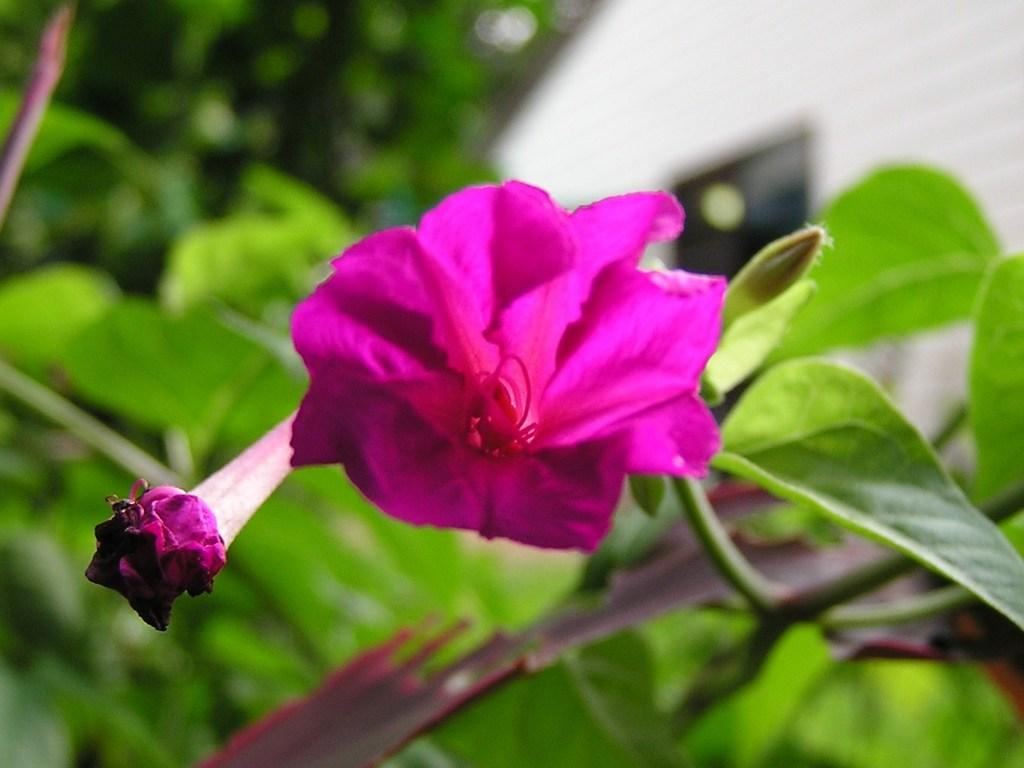What color is the flower in the image? The flower in the image is pink. What type of plant does the flower belong to? The flower belongs to a plant. Can you describe the background of the image? The background of the image is blurred. How many beams of light can be seen coming from the flower in the image? There are no beams of light visible in the image; it only features a pink flower and a blurred background. 